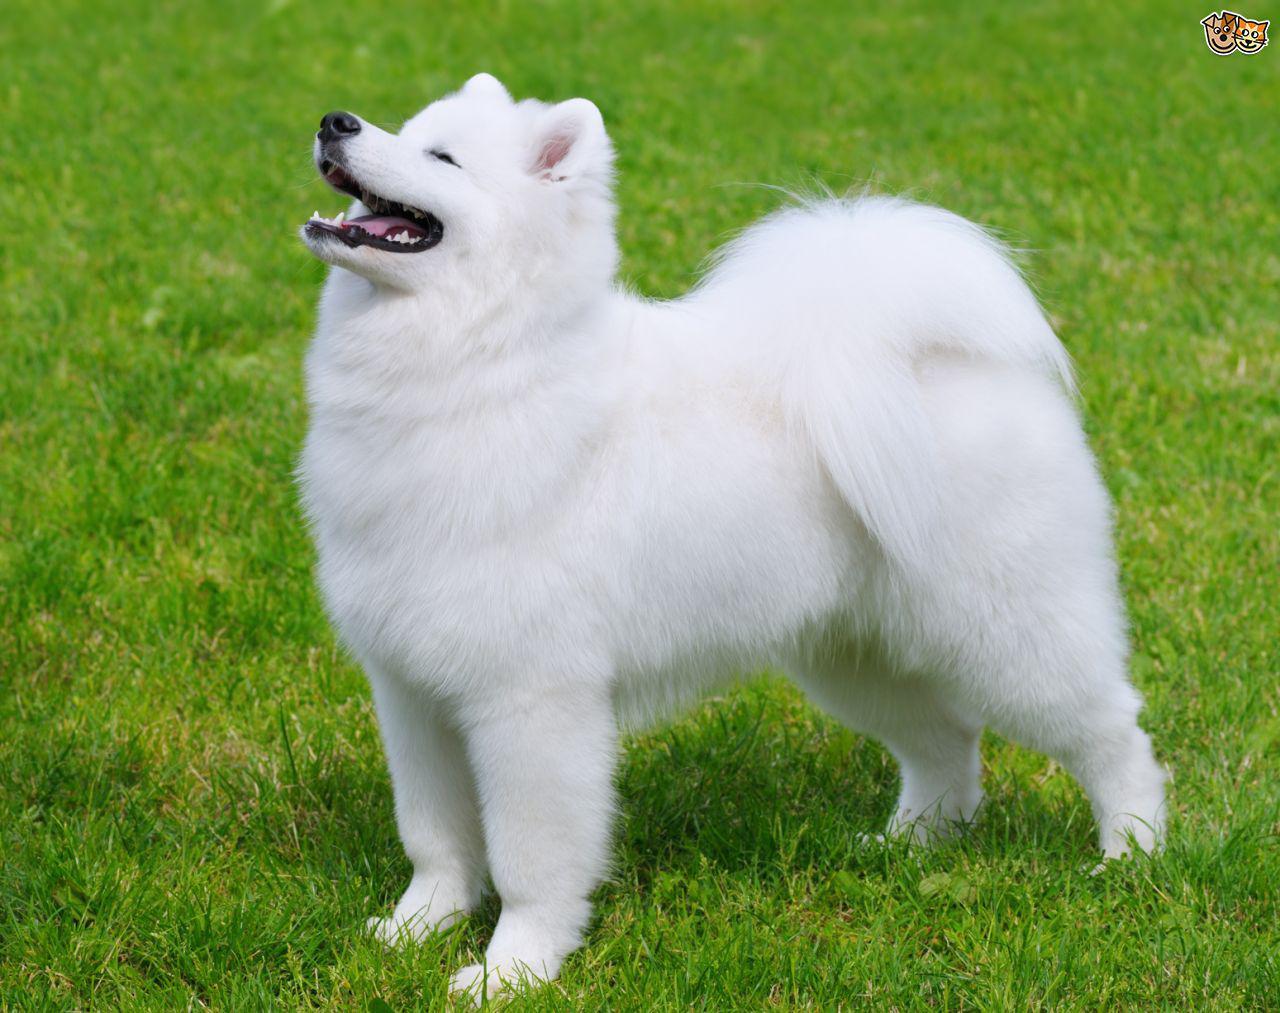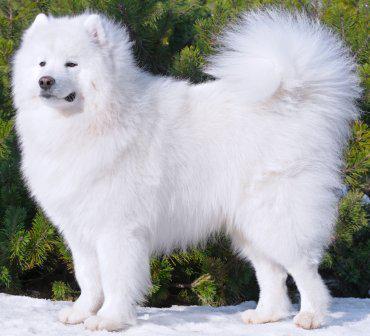The first image is the image on the left, the second image is the image on the right. Analyze the images presented: Is the assertion "The dogs appear to be facing each other." valid? Answer yes or no. No. 